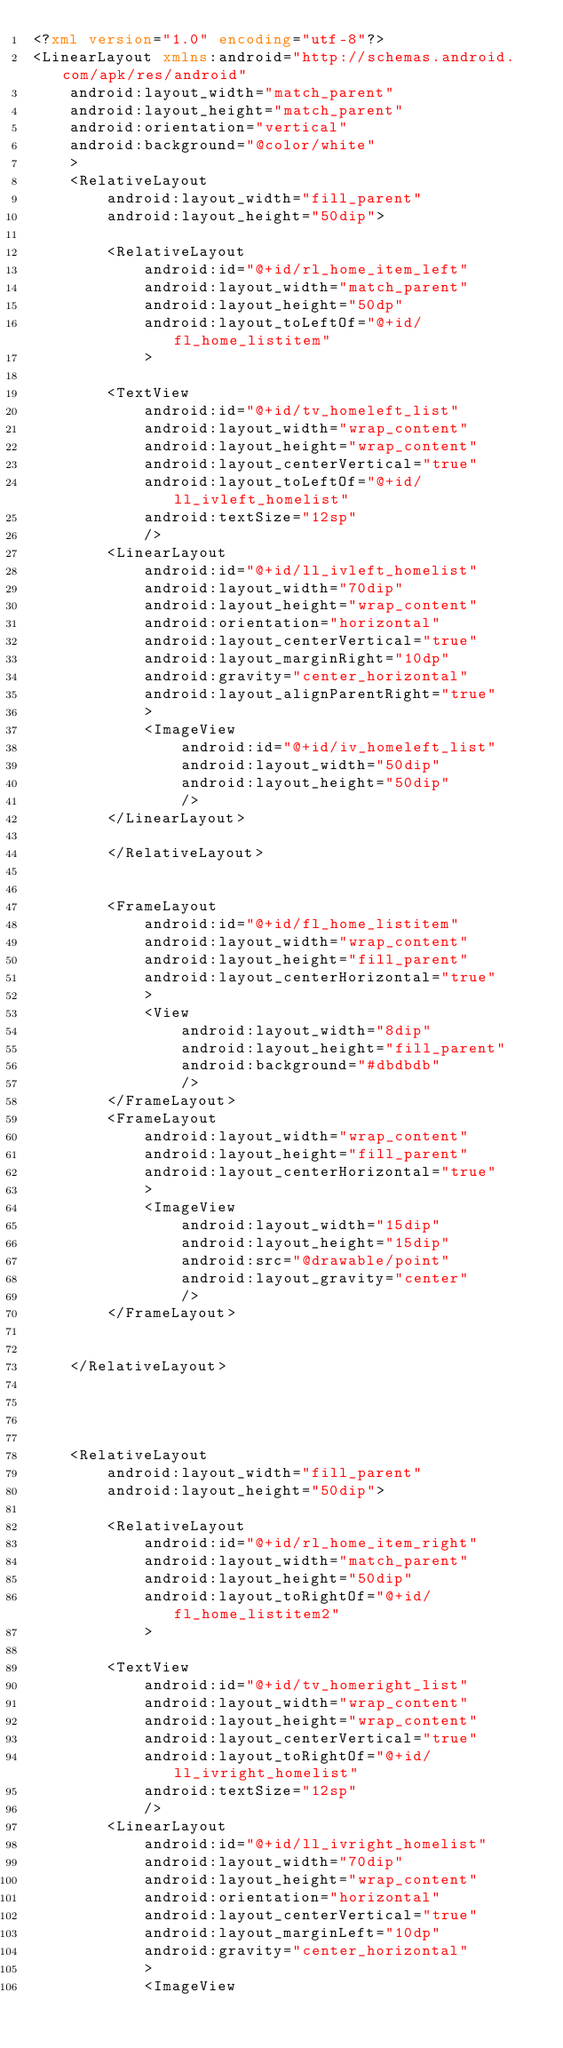<code> <loc_0><loc_0><loc_500><loc_500><_XML_><?xml version="1.0" encoding="utf-8"?>
<LinearLayout xmlns:android="http://schemas.android.com/apk/res/android"
    android:layout_width="match_parent"
    android:layout_height="match_parent"
    android:orientation="vertical"
    android:background="@color/white"
    >
    <RelativeLayout
        android:layout_width="fill_parent"
        android:layout_height="50dip">

        <RelativeLayout
            android:id="@+id/rl_home_item_left"
            android:layout_width="match_parent"
            android:layout_height="50dp"
            android:layout_toLeftOf="@+id/fl_home_listitem"
            >

        <TextView
            android:id="@+id/tv_homeleft_list"
            android:layout_width="wrap_content"
            android:layout_height="wrap_content"
            android:layout_centerVertical="true"
            android:layout_toLeftOf="@+id/ll_ivleft_homelist"
            android:textSize="12sp"
            />
        <LinearLayout
            android:id="@+id/ll_ivleft_homelist"
            android:layout_width="70dip"
            android:layout_height="wrap_content"
            android:orientation="horizontal"
            android:layout_centerVertical="true"
            android:layout_marginRight="10dp"
            android:gravity="center_horizontal"
            android:layout_alignParentRight="true"
            >
            <ImageView
                android:id="@+id/iv_homeleft_list"
                android:layout_width="50dip"
                android:layout_height="50dip"
                />
        </LinearLayout>

        </RelativeLayout>


        <FrameLayout
            android:id="@+id/fl_home_listitem"
            android:layout_width="wrap_content"
            android:layout_height="fill_parent"
            android:layout_centerHorizontal="true"
            >
            <View
                android:layout_width="8dip"
                android:layout_height="fill_parent"
                android:background="#dbdbdb"
                />
        </FrameLayout>
        <FrameLayout
            android:layout_width="wrap_content"
            android:layout_height="fill_parent"
            android:layout_centerHorizontal="true"
            >
            <ImageView
                android:layout_width="15dip"
                android:layout_height="15dip"
                android:src="@drawable/point"
                android:layout_gravity="center"
                />
        </FrameLayout>


    </RelativeLayout>




    <RelativeLayout
        android:layout_width="fill_parent"
        android:layout_height="50dip">

        <RelativeLayout
            android:id="@+id/rl_home_item_right"
            android:layout_width="match_parent"
            android:layout_height="50dip"
            android:layout_toRightOf="@+id/fl_home_listitem2"
            >

        <TextView
            android:id="@+id/tv_homeright_list"
            android:layout_width="wrap_content"
            android:layout_height="wrap_content"
            android:layout_centerVertical="true"
            android:layout_toRightOf="@+id/ll_ivright_homelist"
            android:textSize="12sp"
            />
        <LinearLayout
            android:id="@+id/ll_ivright_homelist"
            android:layout_width="70dip"
            android:layout_height="wrap_content"
            android:orientation="horizontal"
            android:layout_centerVertical="true"
            android:layout_marginLeft="10dp"
            android:gravity="center_horizontal"
            >
            <ImageView</code> 